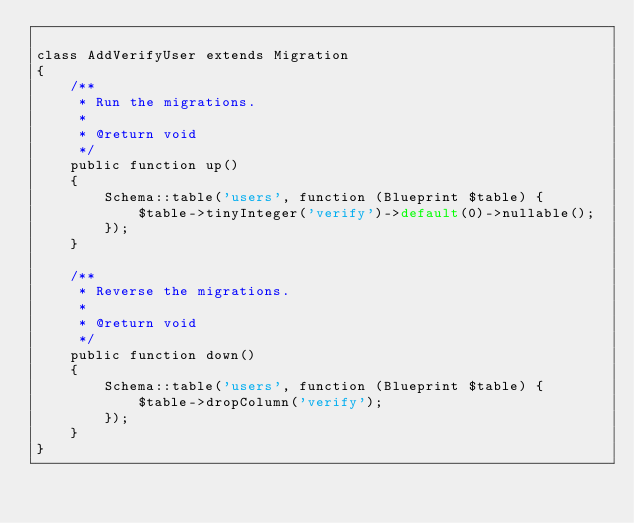Convert code to text. <code><loc_0><loc_0><loc_500><loc_500><_PHP_>
class AddVerifyUser extends Migration
{
    /**
     * Run the migrations.
     *
     * @return void
     */
    public function up()
    {
        Schema::table('users', function (Blueprint $table) {
            $table->tinyInteger('verify')->default(0)->nullable();
        });
    }

    /**
     * Reverse the migrations.
     *
     * @return void
     */
    public function down()
    {
        Schema::table('users', function (Blueprint $table) {
            $table->dropColumn('verify');
        });
    }
}
</code> 